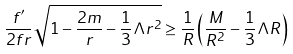Convert formula to latex. <formula><loc_0><loc_0><loc_500><loc_500>\frac { f ^ { \prime } } { 2 f r } \sqrt { 1 - \frac { 2 m } { r } - \frac { 1 } { 3 } \Lambda r ^ { 2 } } \geq \frac { 1 } { R } \left ( \frac { M } { R ^ { 2 } } - \frac { 1 } { 3 } \Lambda R \right )</formula> 